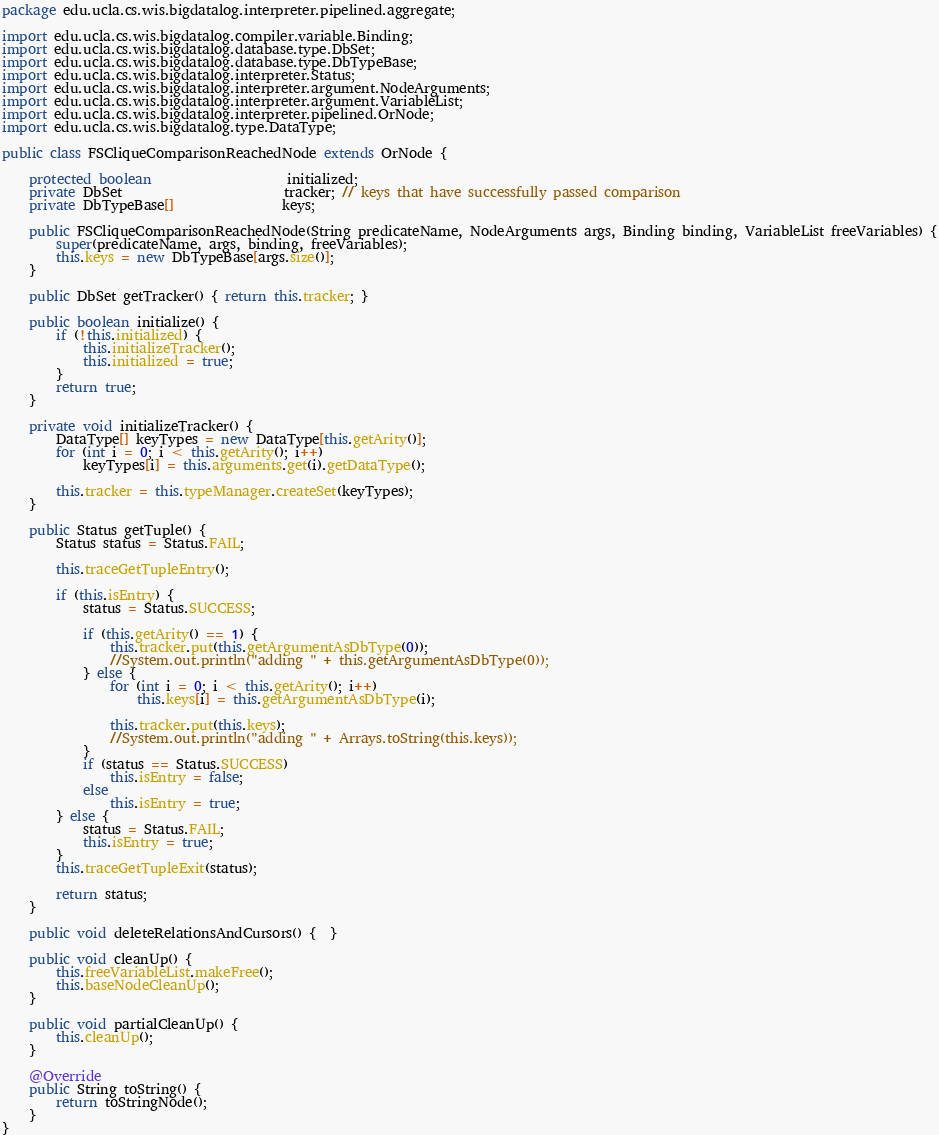Convert code to text. <code><loc_0><loc_0><loc_500><loc_500><_Java_>package edu.ucla.cs.wis.bigdatalog.interpreter.pipelined.aggregate;

import edu.ucla.cs.wis.bigdatalog.compiler.variable.Binding;
import edu.ucla.cs.wis.bigdatalog.database.type.DbSet;
import edu.ucla.cs.wis.bigdatalog.database.type.DbTypeBase;
import edu.ucla.cs.wis.bigdatalog.interpreter.Status;
import edu.ucla.cs.wis.bigdatalog.interpreter.argument.NodeArguments;
import edu.ucla.cs.wis.bigdatalog.interpreter.argument.VariableList;
import edu.ucla.cs.wis.bigdatalog.interpreter.pipelined.OrNode;
import edu.ucla.cs.wis.bigdatalog.type.DataType;

public class FSCliqueComparisonReachedNode extends OrNode {

	protected boolean 					initialized;
	private DbSet						tracker; // keys that have successfully passed comparison
	private DbTypeBase[] 				keys;	
	
	public FSCliqueComparisonReachedNode(String predicateName, NodeArguments args, Binding binding, VariableList freeVariables) {
		super(predicateName, args, binding, freeVariables);
		this.keys = new DbTypeBase[args.size()];
	}
		
	public DbSet getTracker() { return this.tracker; }

	public boolean initialize() {
		if (!this.initialized) {
			this.initializeTracker();				
			this.initialized = true;
		}
		return true; 
	}
	
	private void initializeTracker() {		
		DataType[] keyTypes = new DataType[this.getArity()];
		for (int i = 0; i < this.getArity(); i++)
			keyTypes[i] = this.arguments.get(i).getDataType();
		
		this.tracker = this.typeManager.createSet(keyTypes);	
	}
	
	public Status getTuple() {
		Status status = Status.FAIL;
	  
		this.traceGetTupleEntry();

		if (this.isEntry) {
			status = Status.SUCCESS;
			
			if (this.getArity() == 1) {
				this.tracker.put(this.getArgumentAsDbType(0));
				//System.out.println("adding " + this.getArgumentAsDbType(0));
			} else {
				for (int i = 0; i < this.getArity(); i++)
					this.keys[i] = this.getArgumentAsDbType(i);
				
				this.tracker.put(this.keys);
				//System.out.println("adding " + Arrays.toString(this.keys));
			}			
			if (status == Status.SUCCESS)
				this.isEntry = false;
			else
				this.isEntry = true;
		} else {
			status = Status.FAIL;
			this.isEntry = true;
		}
		this.traceGetTupleExit(status);

		return status;
	}
	
	public void deleteRelationsAndCursors() {  }

	public void cleanUp() {
		this.freeVariableList.makeFree();
		this.baseNodeCleanUp();
	}

	public void partialCleanUp() {
		this.cleanUp();
	}

	@Override
	public String toString() {
		return toStringNode();
	}	
}
</code> 